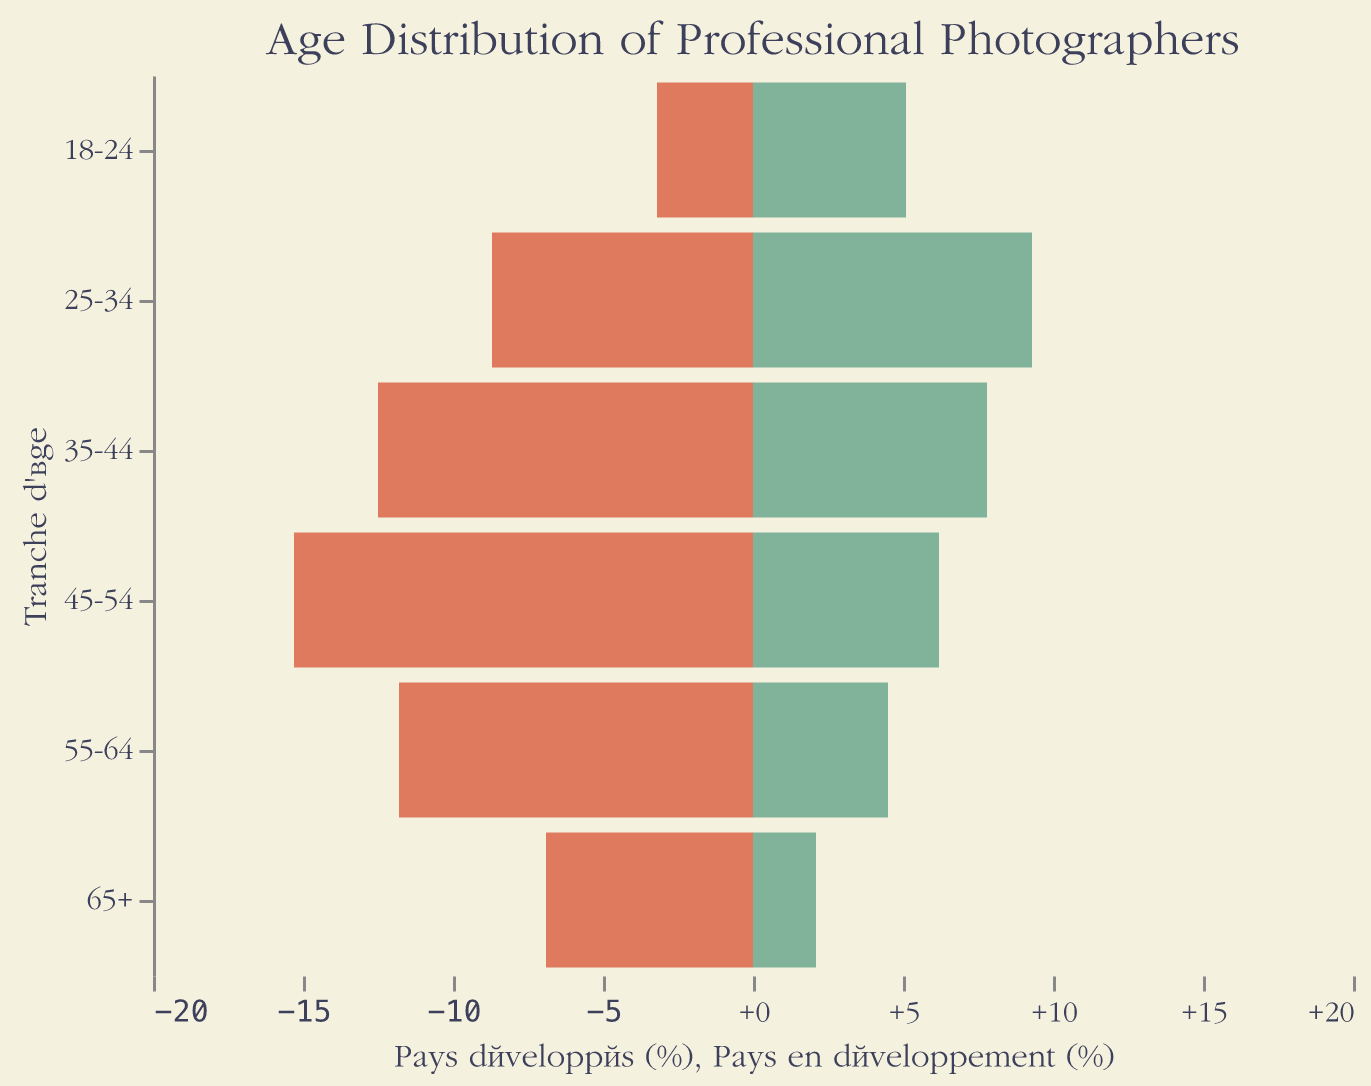What is the title of the figure? The title of the figure is displayed at the top and reads "Age Distribution of Professional Photographers".
Answer: Age Distribution of Professional Photographers What age groups are considered in the figure? The age groups are listed on the y-axis as: 18-24, 25-34, 35-44, 45-54, 55-64, and 65+.
Answer: 18-24, 25-34, 35-44, 45-54, 55-64, 65+ What color represents "Pays développés" in the figure? "Pays développés" is represented by a coral red color. This can be seen on the left side of the pyramid.
Answer: Coral red What is the percentage of professional photographers aged 25-34 in developing countries? The percentage of professional photographers aged 25-34 in developing countries is shown by the length of the bar that extends to the right in the "25-34" age group, marked at 9.3%.
Answer: 9.3% Which age group has the highest percentage of professional photographers in developed countries? The highest bar on the left side, which represents developed countries, is found in the "45-54" age group, marked at 15.3%.
Answer: 45-54 How does the percentage of professional photographers aged 35-44 compare between developed and developing countries? For the 35-44 age group, the bar for developed countries is longer, indicating 12.5%, while the bar for developing countries is shorter, indicating 7.8%. Developed countries have a higher percentage.
Answer: Developed countries have a higher percentage What is the average percentage of professional photographers aged above 45 in developed countries (45-54, 55-64, 65+)? Add the percentages for the 45-54, 55-64, and 65+ age groups in developed countries: 15.3% + 11.8% + 6.9% = 34%. Divide by 3 to get the average: 34% / 3 = 11.33%.
Answer: 11.33% Which age group has the greatest difference in percentage between developed and developing countries? Subtract the percentage for developing countries from developed countries for each age group and find the largest difference. The differences are: 
18-24: 3.2 - 5.1 = -1.9
25-34: 8.7 - 9.3 = -0.6
35-44: 12.5 - 7.8 = 4.7
45-54: 15.3 - 6.2 = 9.1
55-64: 11.8 - 4.5 = 7.3
65+: 6.9 - 2.1 = 4.8
The largest difference is in the 45-54 age group, with a difference of 9.1%.
Answer: 45-54 In which countries (developed or developing) is there a higher percentage of younger professional photographers (aged 18-24 and 25-34 combined)? Add the percentages for the 18-24 and 25-34 age groups in both developed and developing countries. For developed countries: 3.2% + 8.7% = 11.9%. For developing countries: 5.1% + 9.3% = 14.4%. Developing countries have a higher percentage.
Answer: Developing countries What is the total percentage of professional photographers aged 35+ in developing countries? Sum the percentages for the age groups 35-44, 45-54, 55-64, and 65+ in developing countries: 7.8% + 6.2% + 4.5% + 2.1% = 20.6%.
Answer: 20.6% 